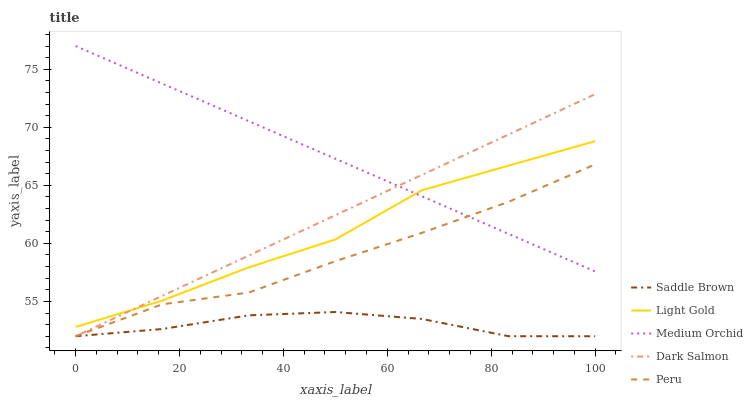Does Saddle Brown have the minimum area under the curve?
Answer yes or no. Yes. Does Medium Orchid have the maximum area under the curve?
Answer yes or no. Yes. Does Light Gold have the minimum area under the curve?
Answer yes or no. No. Does Light Gold have the maximum area under the curve?
Answer yes or no. No. Is Medium Orchid the smoothest?
Answer yes or no. Yes. Is Light Gold the roughest?
Answer yes or no. Yes. Is Saddle Brown the smoothest?
Answer yes or no. No. Is Saddle Brown the roughest?
Answer yes or no. No. Does Saddle Brown have the lowest value?
Answer yes or no. Yes. Does Light Gold have the lowest value?
Answer yes or no. No. Does Medium Orchid have the highest value?
Answer yes or no. Yes. Does Light Gold have the highest value?
Answer yes or no. No. Is Peru less than Light Gold?
Answer yes or no. Yes. Is Medium Orchid greater than Saddle Brown?
Answer yes or no. Yes. Does Light Gold intersect Dark Salmon?
Answer yes or no. Yes. Is Light Gold less than Dark Salmon?
Answer yes or no. No. Is Light Gold greater than Dark Salmon?
Answer yes or no. No. Does Peru intersect Light Gold?
Answer yes or no. No. 